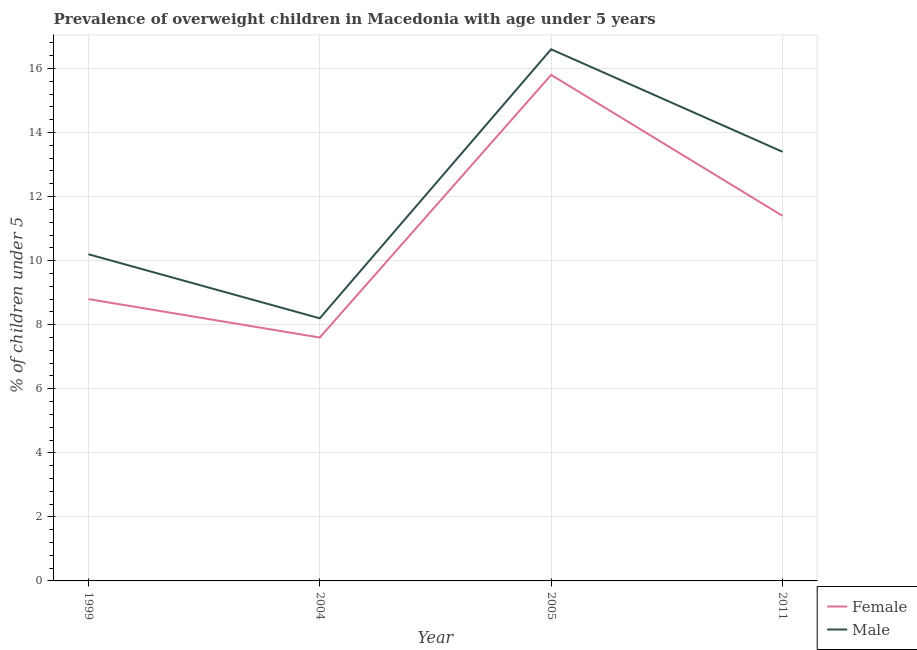What is the percentage of obese female children in 2005?
Provide a succinct answer. 15.8. Across all years, what is the maximum percentage of obese female children?
Make the answer very short. 15.8. Across all years, what is the minimum percentage of obese male children?
Give a very brief answer. 8.2. What is the total percentage of obese female children in the graph?
Offer a very short reply. 43.6. What is the difference between the percentage of obese female children in 2005 and that in 2011?
Your answer should be very brief. 4.4. What is the difference between the percentage of obese male children in 2011 and the percentage of obese female children in 1999?
Provide a succinct answer. 4.6. What is the average percentage of obese female children per year?
Your answer should be compact. 10.9. In the year 2011, what is the difference between the percentage of obese male children and percentage of obese female children?
Make the answer very short. 2. In how many years, is the percentage of obese female children greater than 1.2000000000000002 %?
Offer a terse response. 4. What is the ratio of the percentage of obese male children in 1999 to that in 2004?
Your answer should be compact. 1.24. Is the percentage of obese female children in 1999 less than that in 2005?
Offer a terse response. Yes. Is the difference between the percentage of obese female children in 1999 and 2005 greater than the difference between the percentage of obese male children in 1999 and 2005?
Provide a succinct answer. No. What is the difference between the highest and the second highest percentage of obese female children?
Give a very brief answer. 4.4. What is the difference between the highest and the lowest percentage of obese male children?
Keep it short and to the point. 8.4. In how many years, is the percentage of obese female children greater than the average percentage of obese female children taken over all years?
Offer a very short reply. 2. Is the sum of the percentage of obese female children in 1999 and 2004 greater than the maximum percentage of obese male children across all years?
Your answer should be very brief. No. Is the percentage of obese female children strictly greater than the percentage of obese male children over the years?
Offer a very short reply. No. How many lines are there?
Your response must be concise. 2. Does the graph contain any zero values?
Ensure brevity in your answer.  No. Does the graph contain grids?
Your answer should be compact. Yes. What is the title of the graph?
Ensure brevity in your answer.  Prevalence of overweight children in Macedonia with age under 5 years. Does "Long-term debt" appear as one of the legend labels in the graph?
Your answer should be very brief. No. What is the label or title of the X-axis?
Offer a terse response. Year. What is the label or title of the Y-axis?
Make the answer very short.  % of children under 5. What is the  % of children under 5 of Female in 1999?
Give a very brief answer. 8.8. What is the  % of children under 5 of Male in 1999?
Keep it short and to the point. 10.2. What is the  % of children under 5 in Female in 2004?
Give a very brief answer. 7.6. What is the  % of children under 5 of Male in 2004?
Your answer should be very brief. 8.2. What is the  % of children under 5 in Female in 2005?
Offer a very short reply. 15.8. What is the  % of children under 5 of Male in 2005?
Provide a succinct answer. 16.6. What is the  % of children under 5 of Female in 2011?
Make the answer very short. 11.4. What is the  % of children under 5 in Male in 2011?
Give a very brief answer. 13.4. Across all years, what is the maximum  % of children under 5 in Female?
Offer a very short reply. 15.8. Across all years, what is the maximum  % of children under 5 in Male?
Provide a succinct answer. 16.6. Across all years, what is the minimum  % of children under 5 of Female?
Give a very brief answer. 7.6. Across all years, what is the minimum  % of children under 5 of Male?
Your answer should be compact. 8.2. What is the total  % of children under 5 of Female in the graph?
Provide a short and direct response. 43.6. What is the total  % of children under 5 of Male in the graph?
Your answer should be very brief. 48.4. What is the difference between the  % of children under 5 of Male in 1999 and that in 2004?
Make the answer very short. 2. What is the difference between the  % of children under 5 of Female in 1999 and that in 2005?
Offer a terse response. -7. What is the difference between the  % of children under 5 of Female in 1999 and that in 2011?
Make the answer very short. -2.6. What is the difference between the  % of children under 5 in Male in 1999 and that in 2011?
Give a very brief answer. -3.2. What is the difference between the  % of children under 5 of Female in 2004 and that in 2005?
Offer a terse response. -8.2. What is the difference between the  % of children under 5 of Female in 2004 and that in 2011?
Your answer should be compact. -3.8. What is the difference between the  % of children under 5 of Female in 2005 and that in 2011?
Ensure brevity in your answer.  4.4. What is the difference between the  % of children under 5 of Male in 2005 and that in 2011?
Make the answer very short. 3.2. What is the difference between the  % of children under 5 in Female in 1999 and the  % of children under 5 in Male in 2004?
Ensure brevity in your answer.  0.6. What is the difference between the  % of children under 5 of Female in 1999 and the  % of children under 5 of Male in 2011?
Your answer should be compact. -4.6. What is the difference between the  % of children under 5 of Female in 2004 and the  % of children under 5 of Male in 2005?
Offer a terse response. -9. What is the difference between the  % of children under 5 in Female in 2004 and the  % of children under 5 in Male in 2011?
Offer a terse response. -5.8. What is the average  % of children under 5 in Female per year?
Provide a succinct answer. 10.9. What is the average  % of children under 5 in Male per year?
Keep it short and to the point. 12.1. In the year 2004, what is the difference between the  % of children under 5 of Female and  % of children under 5 of Male?
Provide a short and direct response. -0.6. What is the ratio of the  % of children under 5 in Female in 1999 to that in 2004?
Provide a short and direct response. 1.16. What is the ratio of the  % of children under 5 in Male in 1999 to that in 2004?
Provide a short and direct response. 1.24. What is the ratio of the  % of children under 5 in Female in 1999 to that in 2005?
Your answer should be compact. 0.56. What is the ratio of the  % of children under 5 in Male in 1999 to that in 2005?
Provide a succinct answer. 0.61. What is the ratio of the  % of children under 5 in Female in 1999 to that in 2011?
Provide a short and direct response. 0.77. What is the ratio of the  % of children under 5 in Male in 1999 to that in 2011?
Provide a succinct answer. 0.76. What is the ratio of the  % of children under 5 of Female in 2004 to that in 2005?
Offer a very short reply. 0.48. What is the ratio of the  % of children under 5 of Male in 2004 to that in 2005?
Offer a terse response. 0.49. What is the ratio of the  % of children under 5 in Male in 2004 to that in 2011?
Provide a short and direct response. 0.61. What is the ratio of the  % of children under 5 in Female in 2005 to that in 2011?
Your answer should be compact. 1.39. What is the ratio of the  % of children under 5 of Male in 2005 to that in 2011?
Offer a very short reply. 1.24. What is the difference between the highest and the second highest  % of children under 5 in Male?
Your answer should be compact. 3.2. What is the difference between the highest and the lowest  % of children under 5 in Female?
Provide a short and direct response. 8.2. 